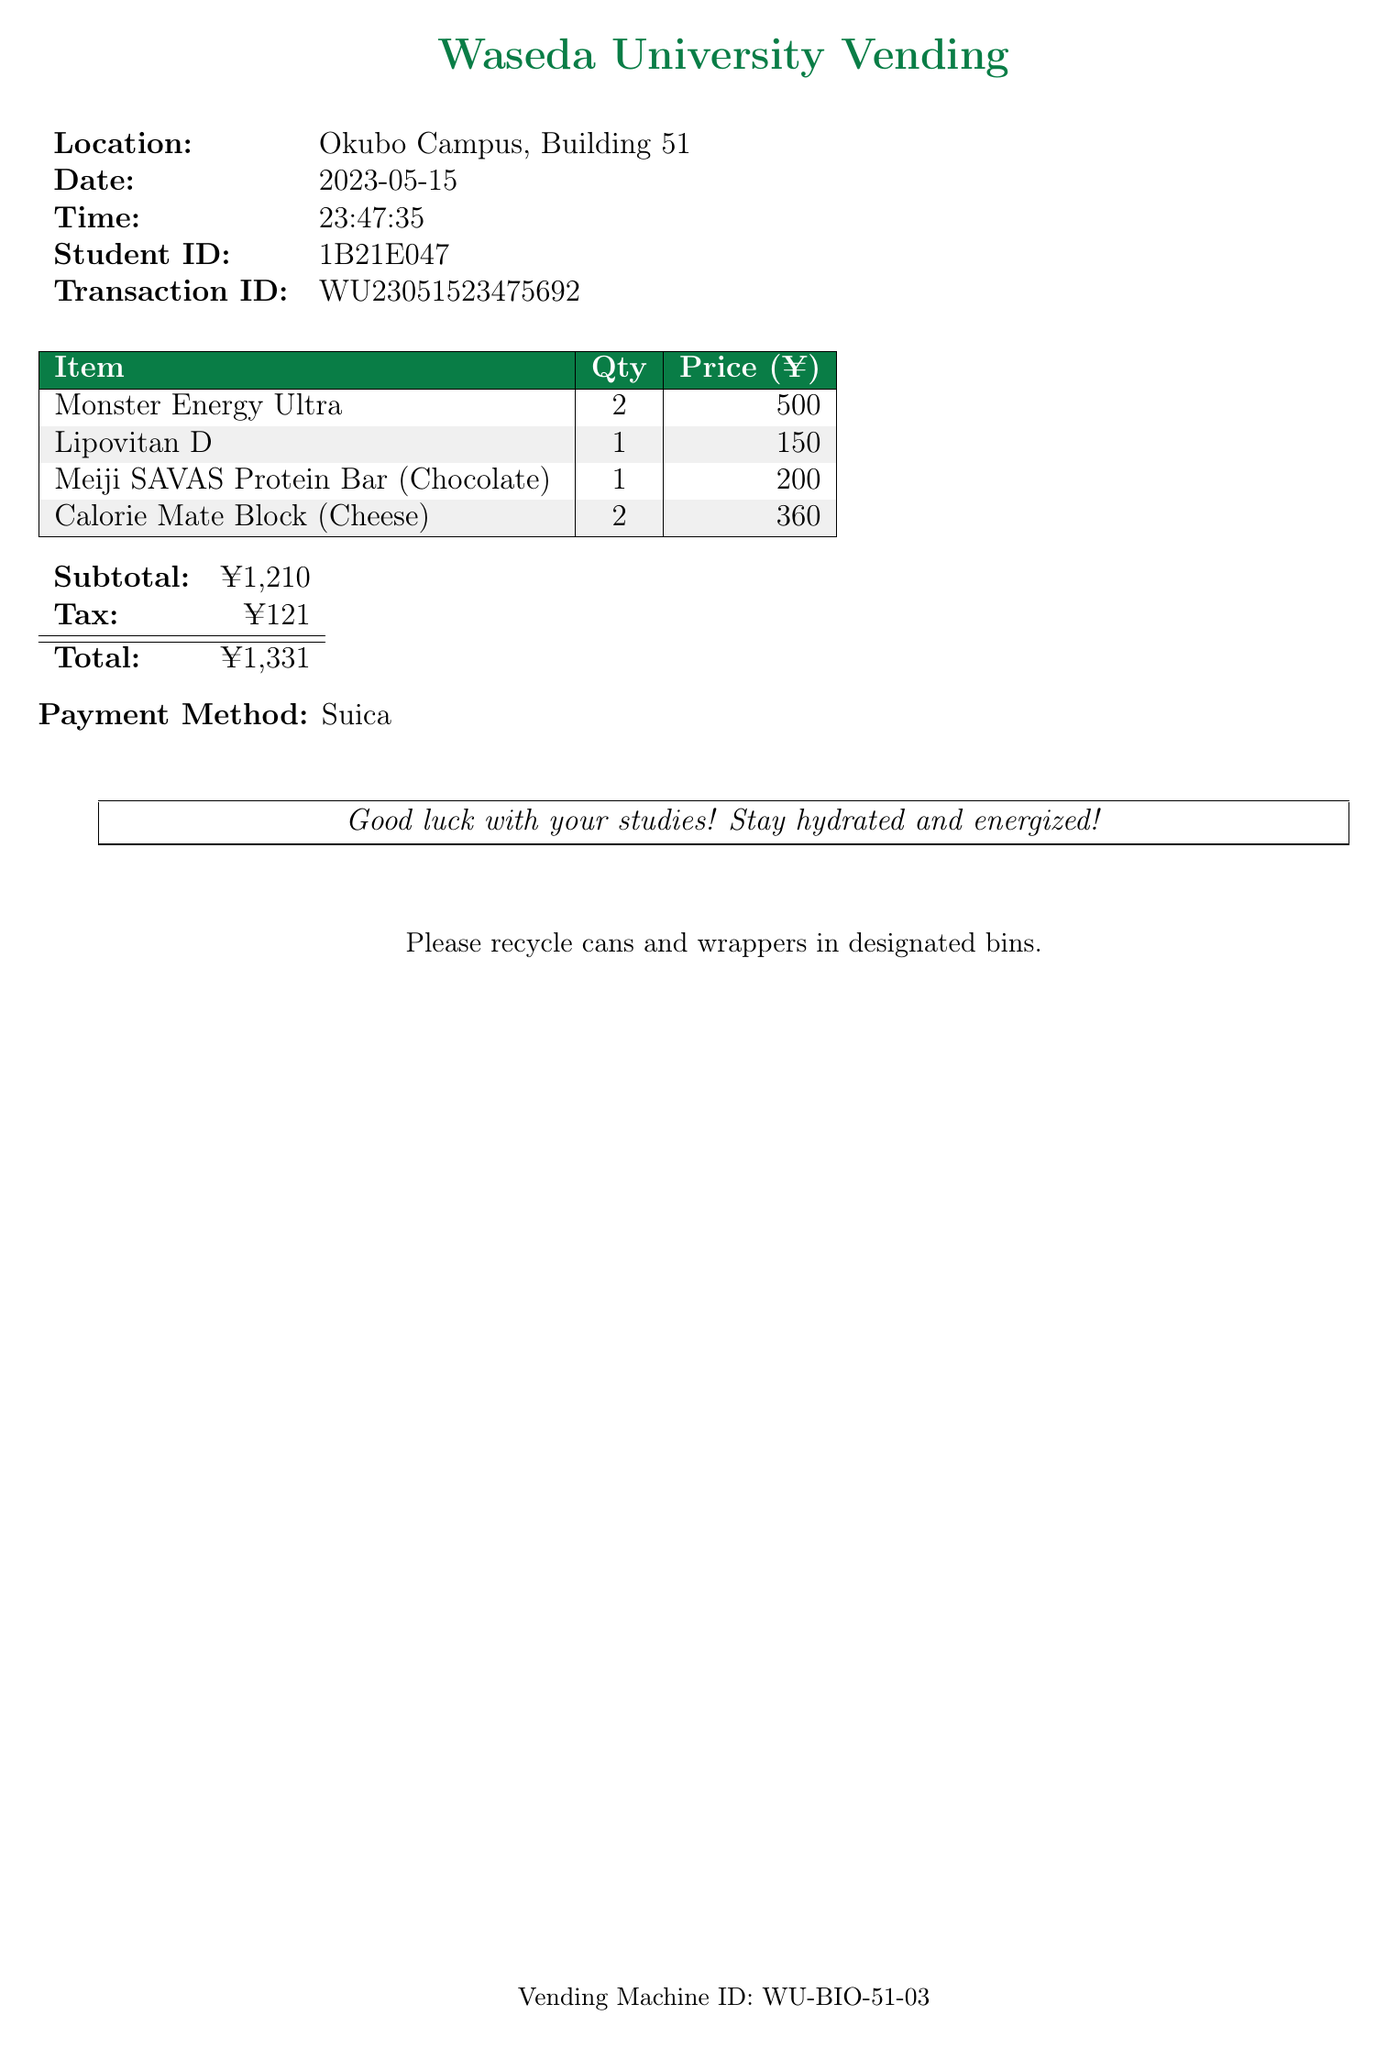What is the store name? The store name can be found at the top of the receipt.
Answer: Waseda University Vending What date was the purchase made? The date appears in the information block on the receipt.
Answer: 2023-05-15 How many Monster Energy Ultras were purchased? The quantity of each item is listed in the itemized section of the receipt.
Answer: 2 What is the total amount spent? The total amount is shown at the bottom of the receipt.
Answer: ¥1,331 What is the payment method used? The payment method is mentioned towards the end of the receipt.
Answer: Suica What is the subtotal before tax? The subtotal is detailed in the total calculation section of the receipt.
Answer: ¥1,210 How many Calorie Mate Blocks were included in the purchase? The quantity of Calorie Mate Blocks can be found in the itemized section of the receipt.
Answer: 2 What message is included at the bottom of the receipt? The footer message, intended for encouragement, is visible in a boxed area.
Answer: Good luck with your studies! Stay hydrated and energized! What recycling information is provided? The recycling information is stated towards the bottom of the receipt.
Answer: Please recycle cans and wrappers in designated bins 